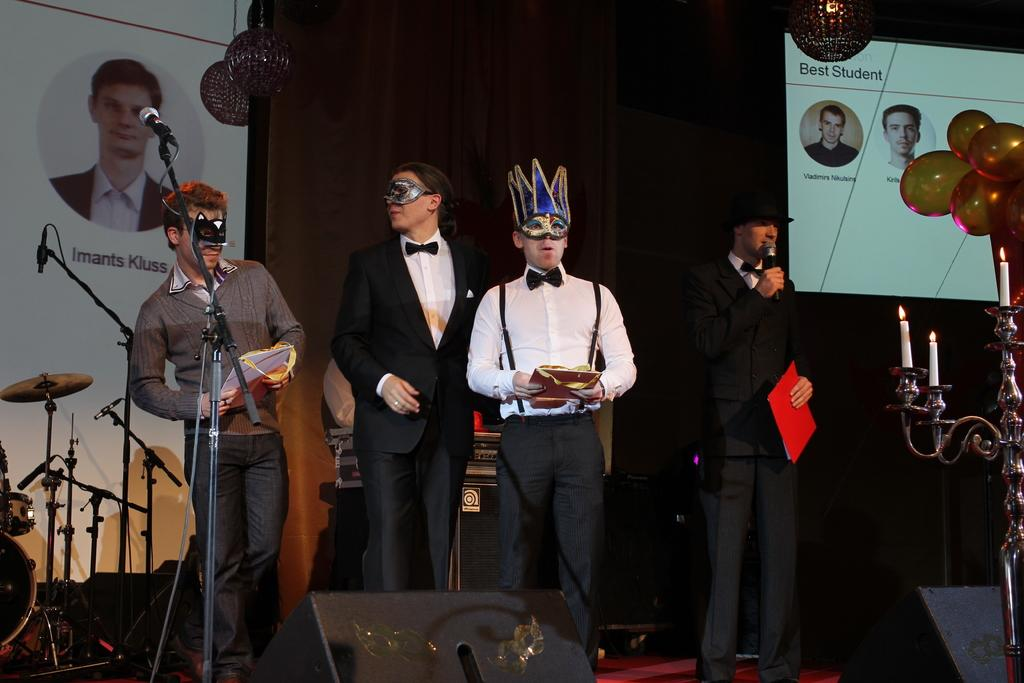How many people are in the image? There are four people in the image. Where are the people located in the image? The people are standing on a stage. What is one person doing in the image? One person is speaking into a microphone. Which side of the stage is the person speaking located? The person speaking is on the right side of the stage. What type of note is the butter holding in the image? There is no butter or note present in the image. 